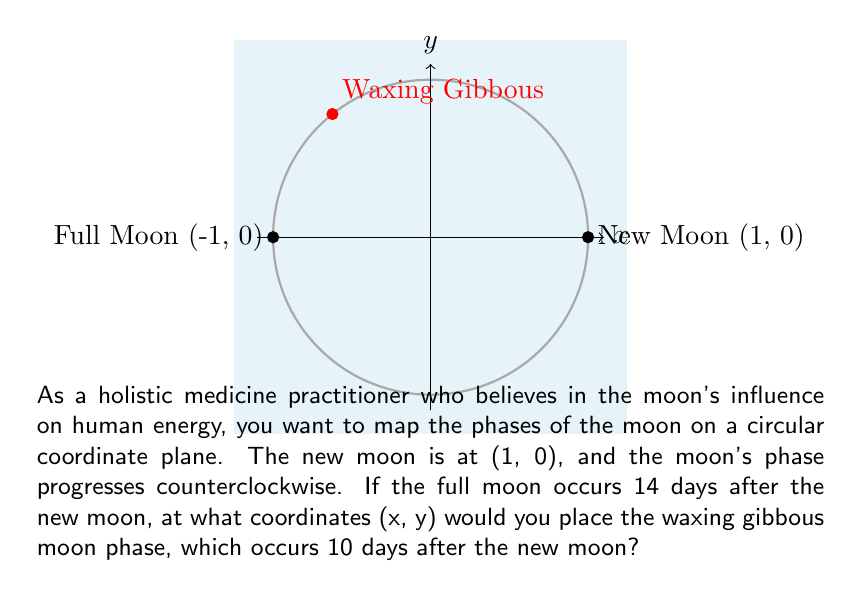Provide a solution to this math problem. To solve this problem, we'll follow these steps:

1) First, we need to understand that the moon's orbit can be represented as a full circle (2π radians) over 28 days.

2) We can calculate the angle θ for the waxing gibbous moon:
   $$ \theta = \frac{10 \text{ days}}{28 \text{ days}} \cdot 2\pi \text{ radians} = \frac{5\pi}{7} \text{ radians} $$

3) Now, we can use the parametric equations for a circle to find the coordinates:
   $$ x = \cos(\theta) $$
   $$ y = \sin(\theta) $$

4) Substituting our angle:
   $$ x = \cos(\frac{5\pi}{7}) $$
   $$ y = \sin(\frac{5\pi}{7}) $$

5) These values can be left in this form, or we can calculate the decimal approximations:
   $$ x \approx -0.2225 $$
   $$ y \approx 0.9749 $$

Therefore, the coordinates for the waxing gibbous moon are $(\cos(\frac{5\pi}{7}), \sin(\frac{5\pi}{7}))$ or approximately (-0.2225, 0.9749).
Answer: $(\cos(\frac{5\pi}{7}), \sin(\frac{5\pi}{7}))$ 